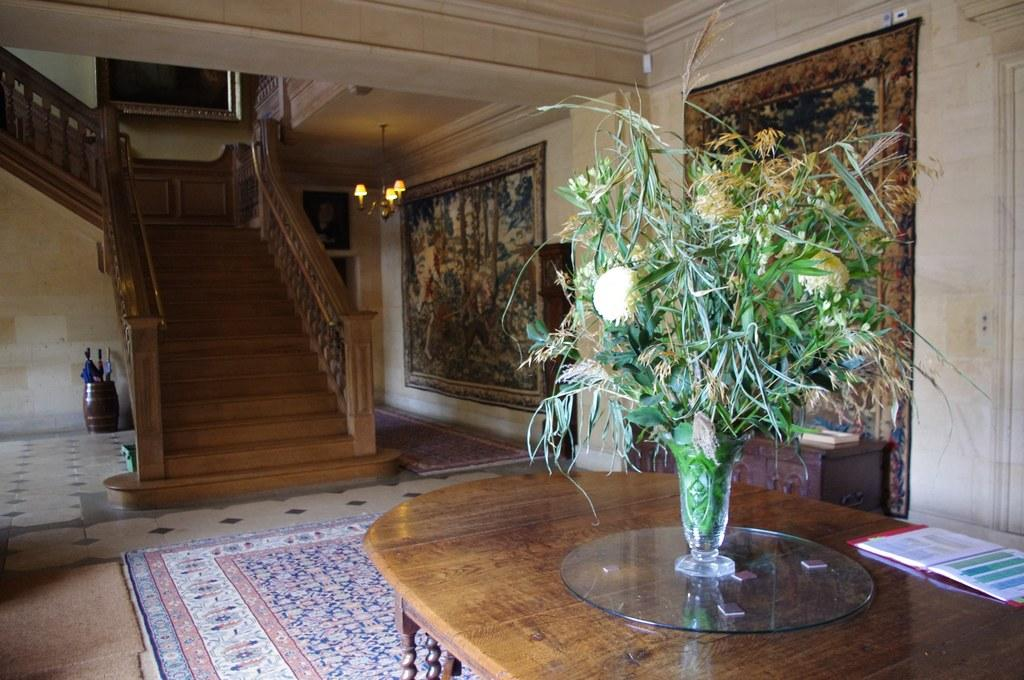What is inside the vase that is visible in the image? There is grass in the vase that is visible in the image. What architectural feature can be seen in the image? There are stairs and a staircase in the image. What type of lighting fixture is present in the image? There is a chandelier in the image. What type of artwork is present on the wall in the image? There is a wall painting in the image. Are there any locks visible in the image? There are no locks present in the image. How many men can be seen in the image? There are no men present in the image. What is the time of day depicted in the image? The time of day cannot be determined from the image, as there is no indication of day or night. 